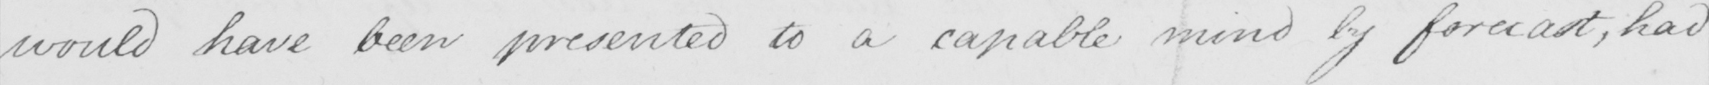Please transcribe the handwritten text in this image. would have been presented to a capable mind by forecast , had 